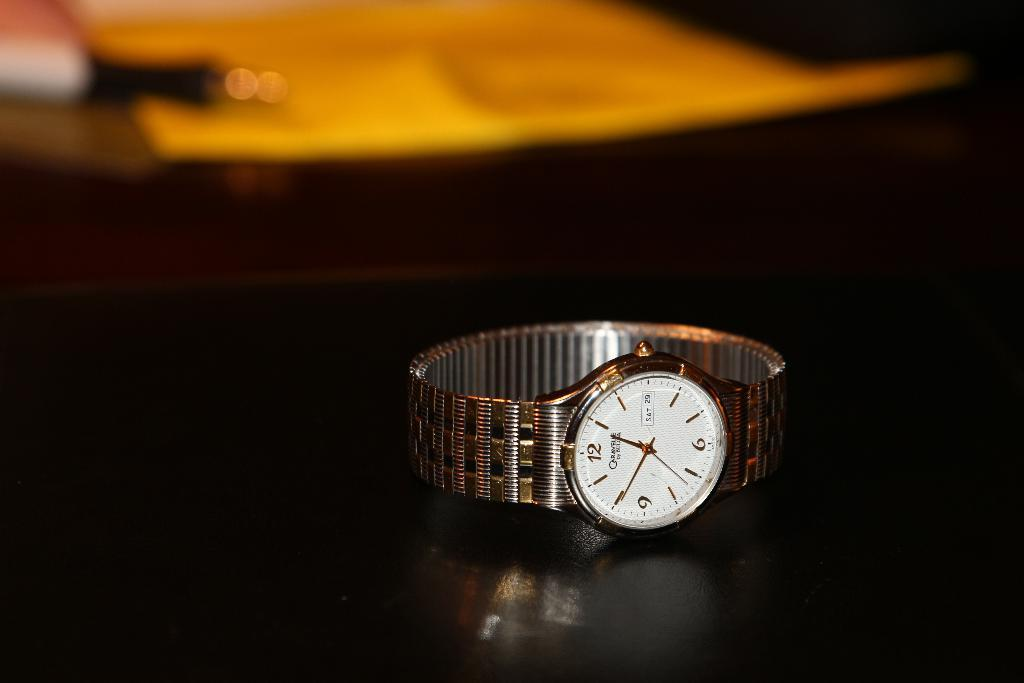<image>
Summarize the visual content of the image. Watch sitting on top of a table which shows the date at SAT 29. 